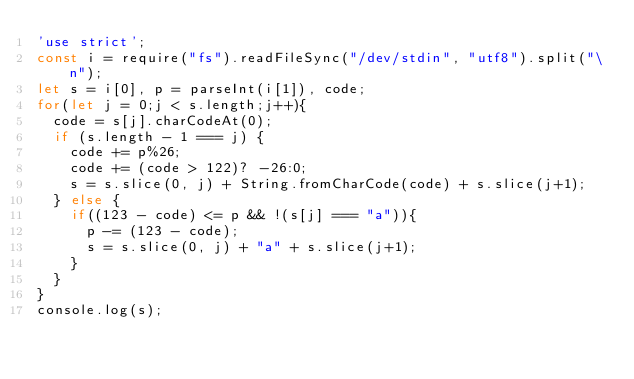<code> <loc_0><loc_0><loc_500><loc_500><_JavaScript_>'use strict';
const i = require("fs").readFileSync("/dev/stdin", "utf8").split("\n");
let s = i[0], p = parseInt(i[1]), code;
for(let j = 0;j < s.length;j++){
  code = s[j].charCodeAt(0);
  if (s.length - 1 === j) {
    code += p%26;
    code += (code > 122)? -26:0;
    s = s.slice(0, j) + String.fromCharCode(code) + s.slice(j+1);
  } else {
    if((123 - code) <= p && !(s[j] === "a")){
      p -= (123 - code);
      s = s.slice(0, j) + "a" + s.slice(j+1);
    }
  }
}
console.log(s);</code> 